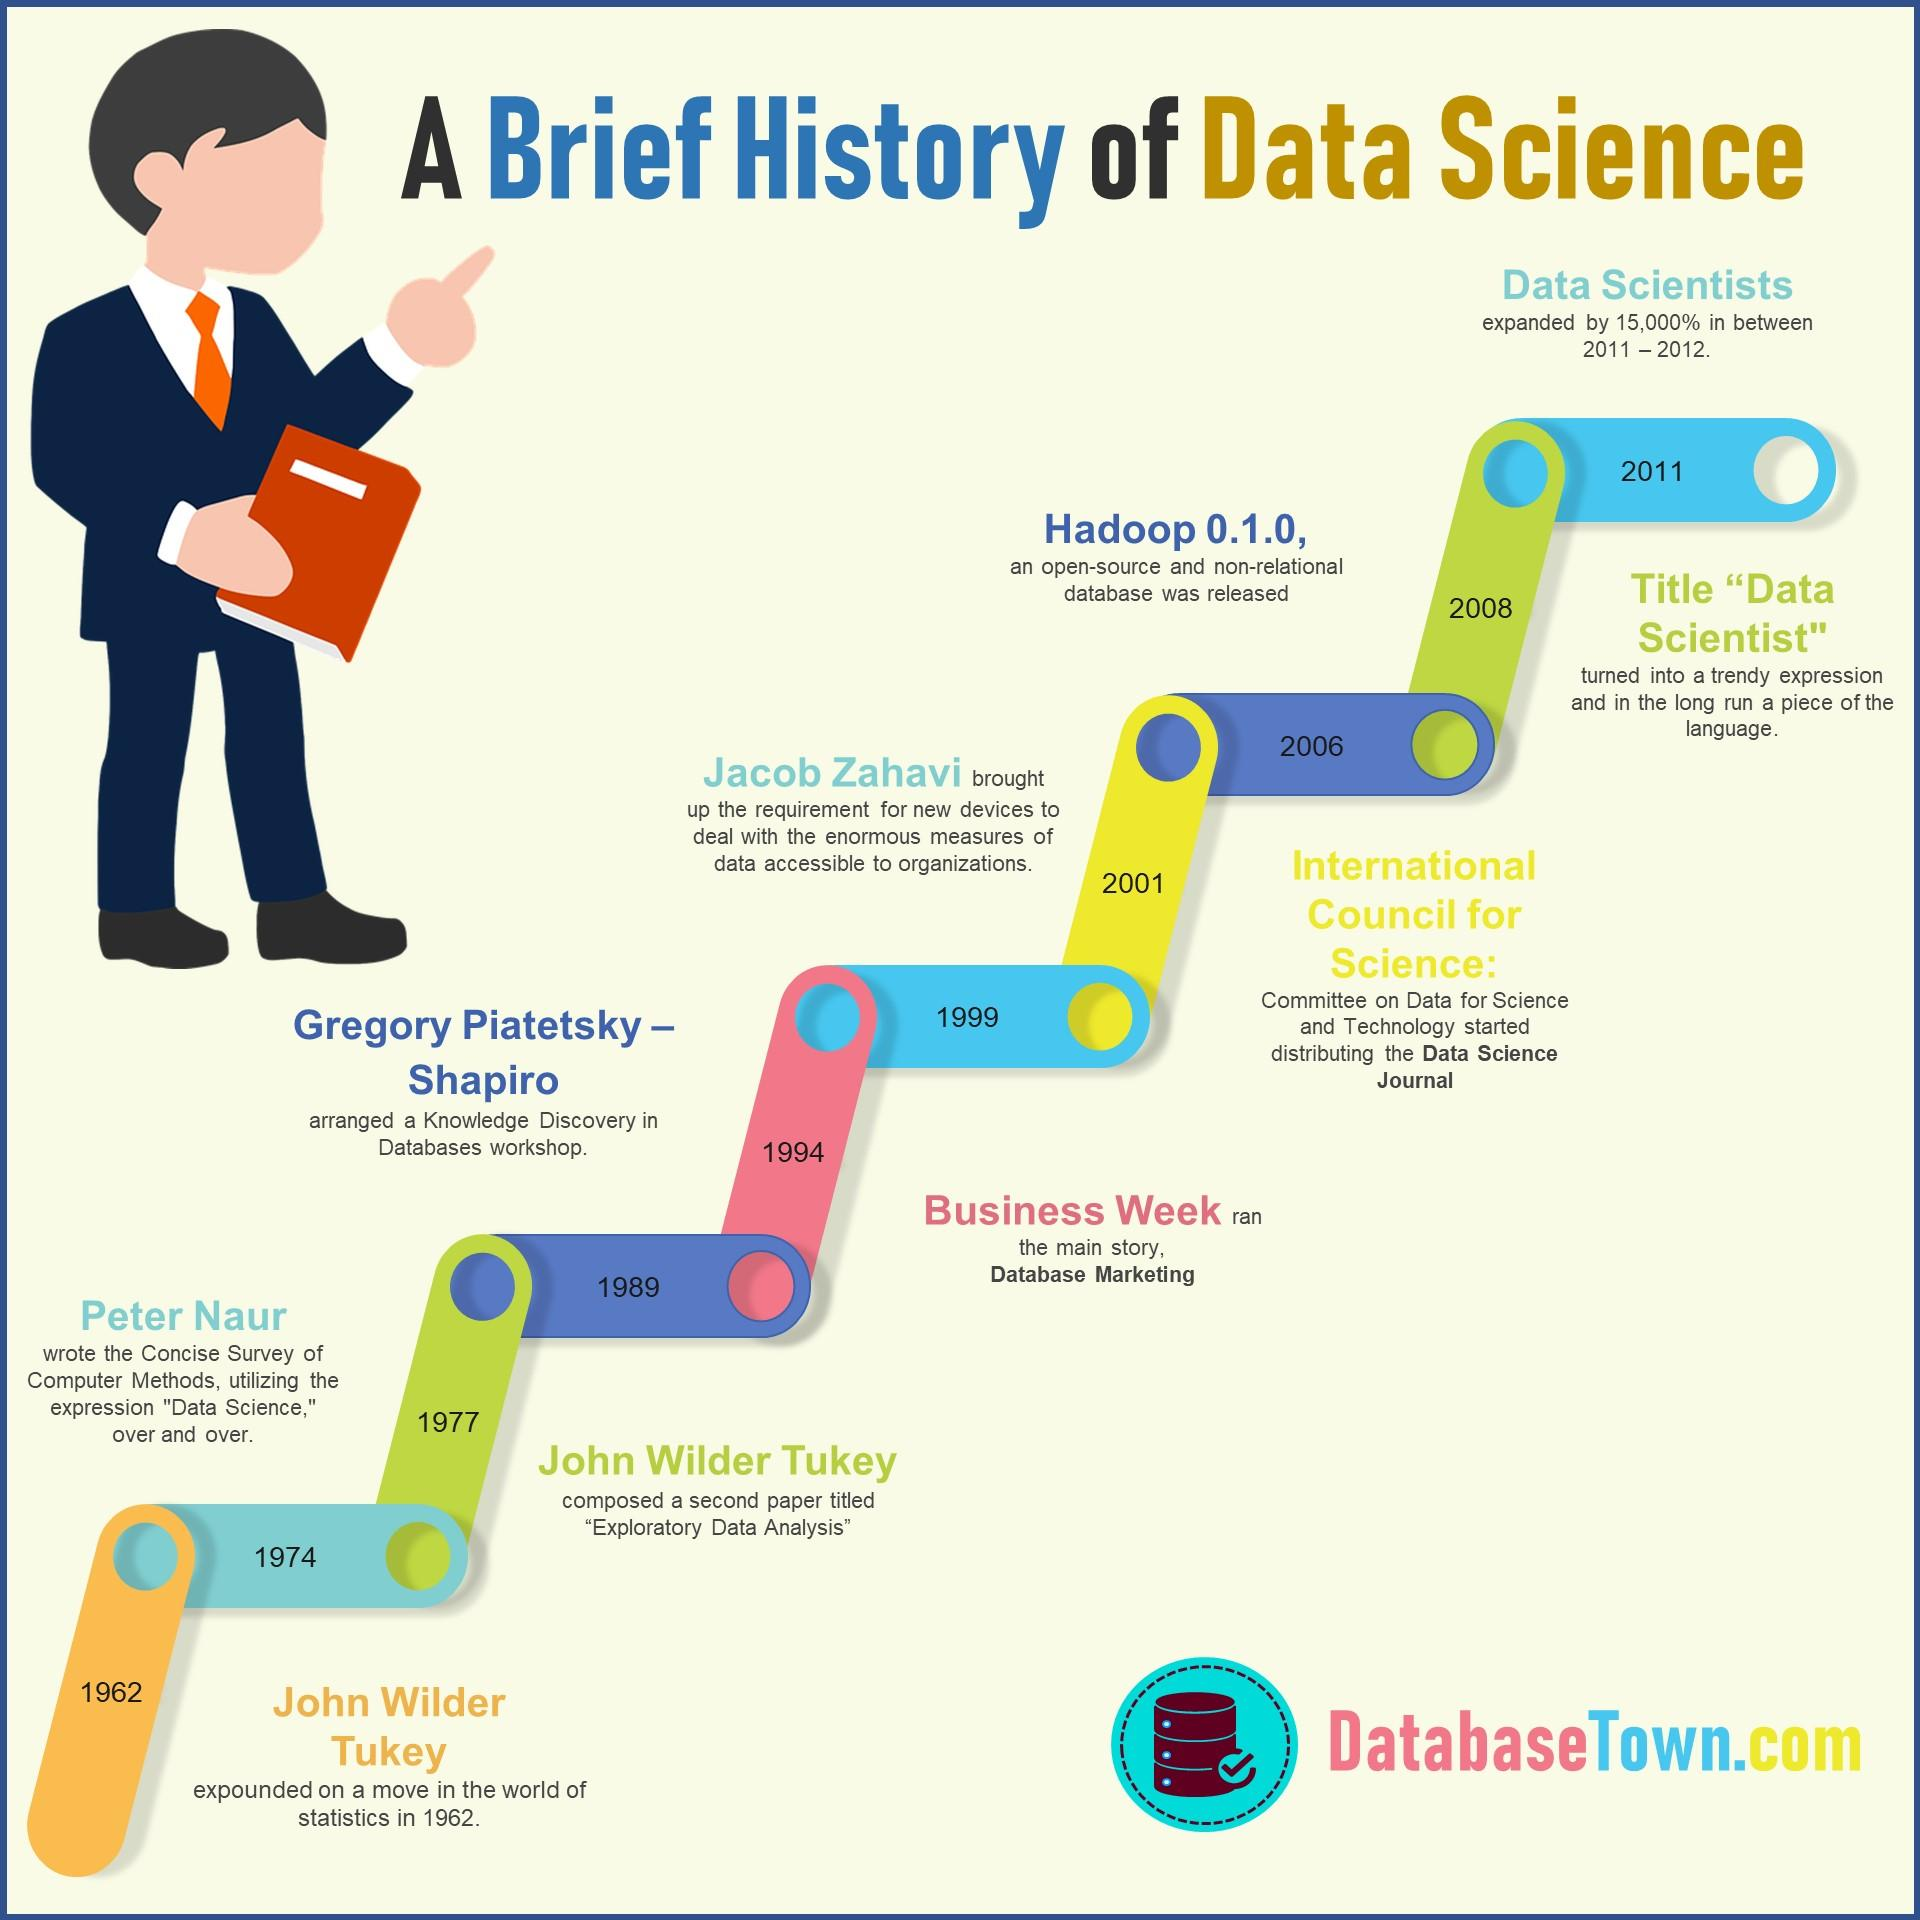Specify some key components in this picture. In 2006, Hadoop 0.1.0 was released. In 1989, Gregory Piatetsky-Shapiro organized a workshop focused on the discovery of knowledge in databases. In 1974, Peter Naur published a concise survey of computer methods. 